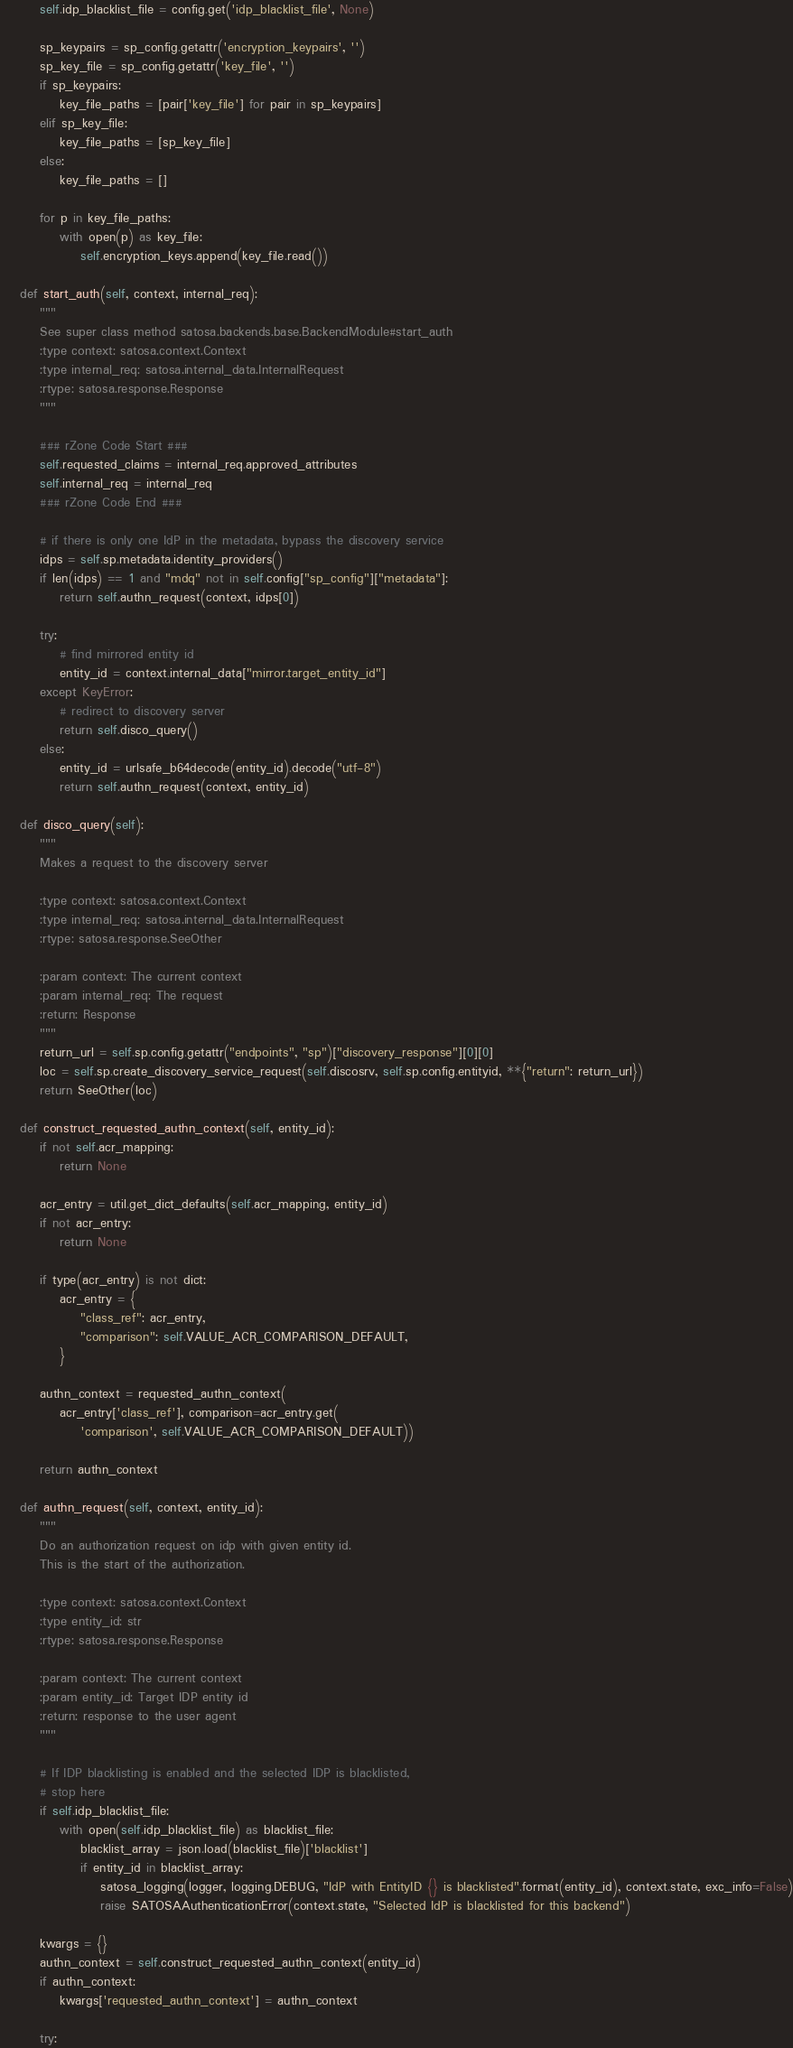<code> <loc_0><loc_0><loc_500><loc_500><_Python_>        self.idp_blacklist_file = config.get('idp_blacklist_file', None)

        sp_keypairs = sp_config.getattr('encryption_keypairs', '')
        sp_key_file = sp_config.getattr('key_file', '')
        if sp_keypairs:
            key_file_paths = [pair['key_file'] for pair in sp_keypairs]
        elif sp_key_file:
            key_file_paths = [sp_key_file]
        else:
            key_file_paths = []

        for p in key_file_paths:
            with open(p) as key_file:
                self.encryption_keys.append(key_file.read())

    def start_auth(self, context, internal_req):
        """
        See super class method satosa.backends.base.BackendModule#start_auth
        :type context: satosa.context.Context
        :type internal_req: satosa.internal_data.InternalRequest
        :rtype: satosa.response.Response
        """

        ### rZone Code Start ###
        self.requested_claims = internal_req.approved_attributes
        self.internal_req = internal_req 
        ### rZone Code End ###

        # if there is only one IdP in the metadata, bypass the discovery service
        idps = self.sp.metadata.identity_providers()
        if len(idps) == 1 and "mdq" not in self.config["sp_config"]["metadata"]:
            return self.authn_request(context, idps[0])

        try:
            # find mirrored entity id
            entity_id = context.internal_data["mirror.target_entity_id"]
        except KeyError:
            # redirect to discovery server
            return self.disco_query()
        else:
            entity_id = urlsafe_b64decode(entity_id).decode("utf-8")
            return self.authn_request(context, entity_id)

    def disco_query(self):
        """
        Makes a request to the discovery server

        :type context: satosa.context.Context
        :type internal_req: satosa.internal_data.InternalRequest
        :rtype: satosa.response.SeeOther

        :param context: The current context
        :param internal_req: The request
        :return: Response
        """
        return_url = self.sp.config.getattr("endpoints", "sp")["discovery_response"][0][0]
        loc = self.sp.create_discovery_service_request(self.discosrv, self.sp.config.entityid, **{"return": return_url})
        return SeeOther(loc)

    def construct_requested_authn_context(self, entity_id):
        if not self.acr_mapping:
            return None

        acr_entry = util.get_dict_defaults(self.acr_mapping, entity_id)
        if not acr_entry:
            return None

        if type(acr_entry) is not dict:
            acr_entry = {
                "class_ref": acr_entry,
                "comparison": self.VALUE_ACR_COMPARISON_DEFAULT,
            }

        authn_context = requested_authn_context(
            acr_entry['class_ref'], comparison=acr_entry.get(
                'comparison', self.VALUE_ACR_COMPARISON_DEFAULT))

        return authn_context

    def authn_request(self, context, entity_id):
        """
        Do an authorization request on idp with given entity id.
        This is the start of the authorization.

        :type context: satosa.context.Context
        :type entity_id: str
        :rtype: satosa.response.Response

        :param context: The current context
        :param entity_id: Target IDP entity id
        :return: response to the user agent
        """

        # If IDP blacklisting is enabled and the selected IDP is blacklisted,
        # stop here
        if self.idp_blacklist_file:
            with open(self.idp_blacklist_file) as blacklist_file:
                blacklist_array = json.load(blacklist_file)['blacklist']
                if entity_id in blacklist_array:
                    satosa_logging(logger, logging.DEBUG, "IdP with EntityID {} is blacklisted".format(entity_id), context.state, exc_info=False)
                    raise SATOSAAuthenticationError(context.state, "Selected IdP is blacklisted for this backend")

        kwargs = {}
        authn_context = self.construct_requested_authn_context(entity_id)
        if authn_context:
            kwargs['requested_authn_context'] = authn_context

        try:</code> 